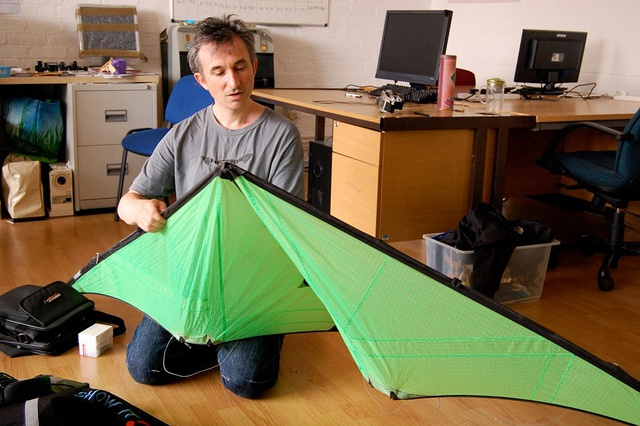Describe the objects in this image and their specific colors. I can see kite in darkgray and lightgreen tones, people in darkgray, black, gray, and lightgray tones, chair in darkgray, black, maroon, darkblue, and gray tones, handbag in darkgray, black, gray, brown, and maroon tones, and backpack in darkgray, black, gray, brown, and maroon tones in this image. 